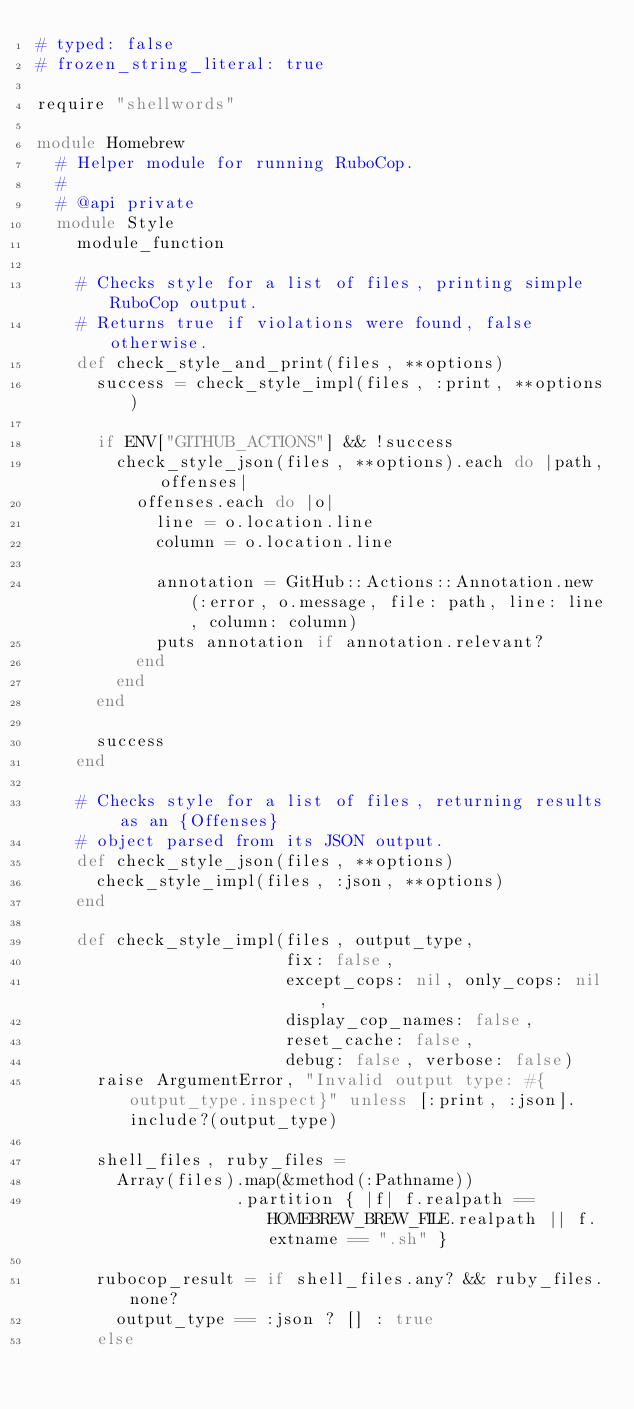Convert code to text. <code><loc_0><loc_0><loc_500><loc_500><_Ruby_># typed: false
# frozen_string_literal: true

require "shellwords"

module Homebrew
  # Helper module for running RuboCop.
  #
  # @api private
  module Style
    module_function

    # Checks style for a list of files, printing simple RuboCop output.
    # Returns true if violations were found, false otherwise.
    def check_style_and_print(files, **options)
      success = check_style_impl(files, :print, **options)

      if ENV["GITHUB_ACTIONS"] && !success
        check_style_json(files, **options).each do |path, offenses|
          offenses.each do |o|
            line = o.location.line
            column = o.location.line

            annotation = GitHub::Actions::Annotation.new(:error, o.message, file: path, line: line, column: column)
            puts annotation if annotation.relevant?
          end
        end
      end

      success
    end

    # Checks style for a list of files, returning results as an {Offenses}
    # object parsed from its JSON output.
    def check_style_json(files, **options)
      check_style_impl(files, :json, **options)
    end

    def check_style_impl(files, output_type,
                         fix: false,
                         except_cops: nil, only_cops: nil,
                         display_cop_names: false,
                         reset_cache: false,
                         debug: false, verbose: false)
      raise ArgumentError, "Invalid output type: #{output_type.inspect}" unless [:print, :json].include?(output_type)

      shell_files, ruby_files =
        Array(files).map(&method(:Pathname))
                    .partition { |f| f.realpath == HOMEBREW_BREW_FILE.realpath || f.extname == ".sh" }

      rubocop_result = if shell_files.any? && ruby_files.none?
        output_type == :json ? [] : true
      else</code> 